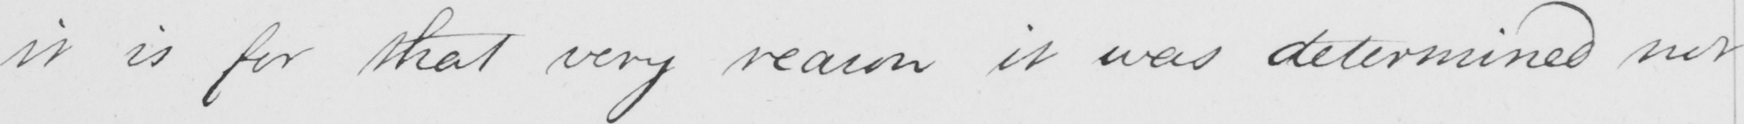What does this handwritten line say? it is for that very reason it was determined not 